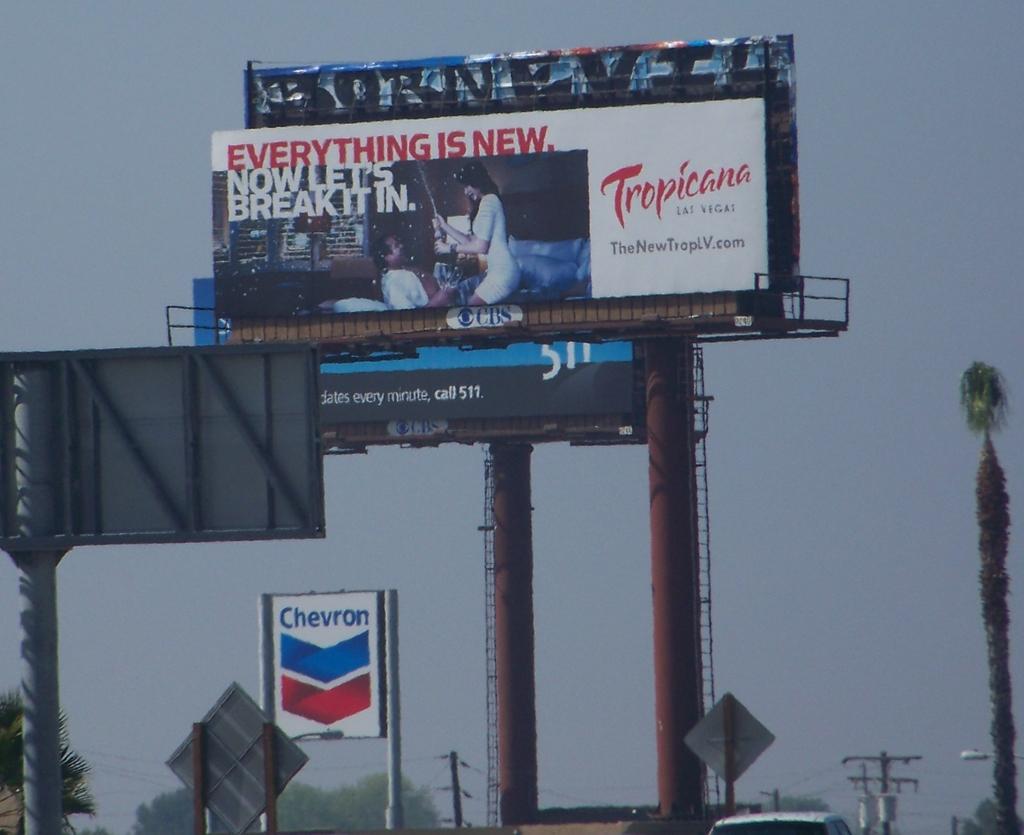What brand is on the big bill board?
Offer a very short reply. Tropicana. 